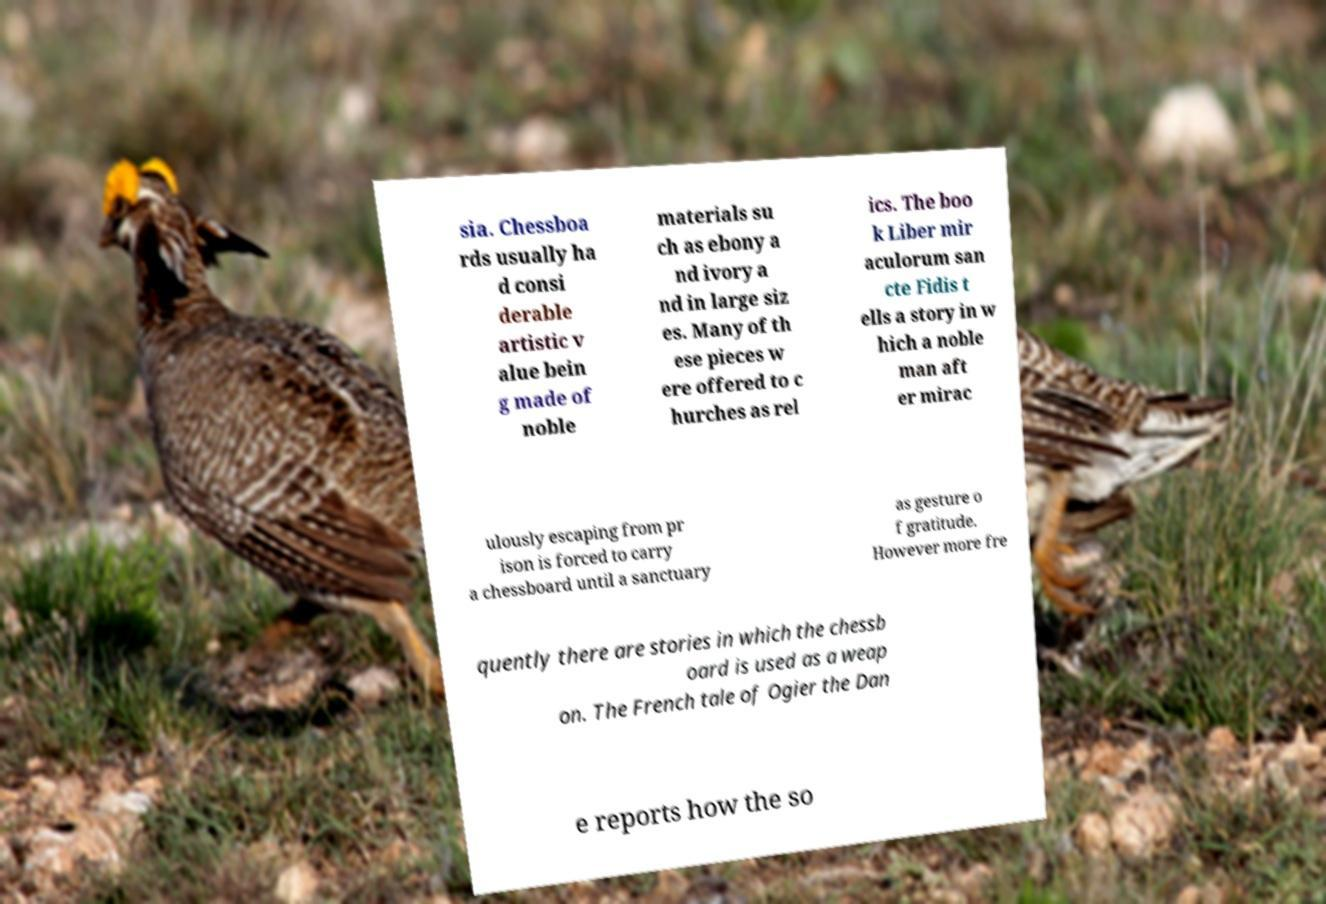Can you accurately transcribe the text from the provided image for me? sia. Chessboa rds usually ha d consi derable artistic v alue bein g made of noble materials su ch as ebony a nd ivory a nd in large siz es. Many of th ese pieces w ere offered to c hurches as rel ics. The boo k Liber mir aculorum san cte Fidis t ells a story in w hich a noble man aft er mirac ulously escaping from pr ison is forced to carry a chessboard until a sanctuary as gesture o f gratitude. However more fre quently there are stories in which the chessb oard is used as a weap on. The French tale of Ogier the Dan e reports how the so 